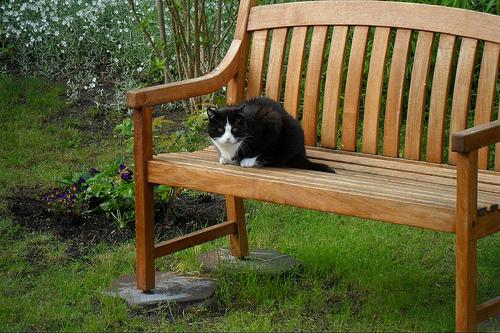Question: what is in the background?
Choices:
A. Trees.
B. Houses.
C. Grass and bushes.
D. Buildings.
Answer with the letter. Answer: C Question: how many cats are in the photo?
Choices:
A. Two.
B. Three.
C. One.
D. Four.
Answer with the letter. Answer: C Question: what is sitting on the bench?
Choices:
A. A bum.
B. A cat.
C. A bottle of cheap whisky.
D. A woman.
Answer with the letter. Answer: B Question: where was this photo taken?
Choices:
A. On the front porch.
B. On the sidewalk.
C. In a garden.
D. By the house.
Answer with the letter. Answer: C 